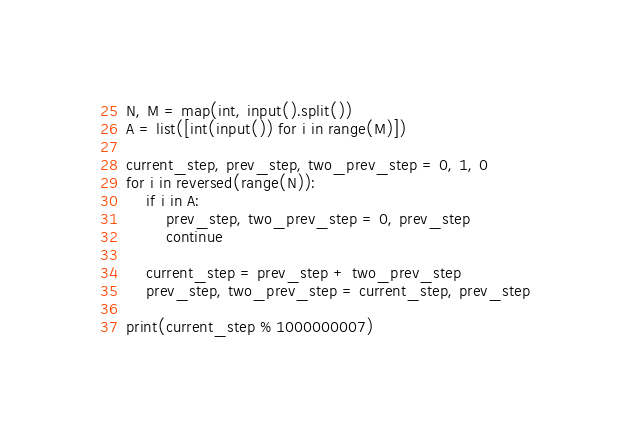<code> <loc_0><loc_0><loc_500><loc_500><_Python_>N, M = map(int, input().split())
A = list([int(input()) for i in range(M)])

current_step, prev_step, two_prev_step = 0, 1, 0
for i in reversed(range(N)):
    if i in A:
        prev_step, two_prev_step = 0, prev_step
        continue

    current_step = prev_step + two_prev_step
    prev_step, two_prev_step = current_step, prev_step

print(current_step % 1000000007)</code> 